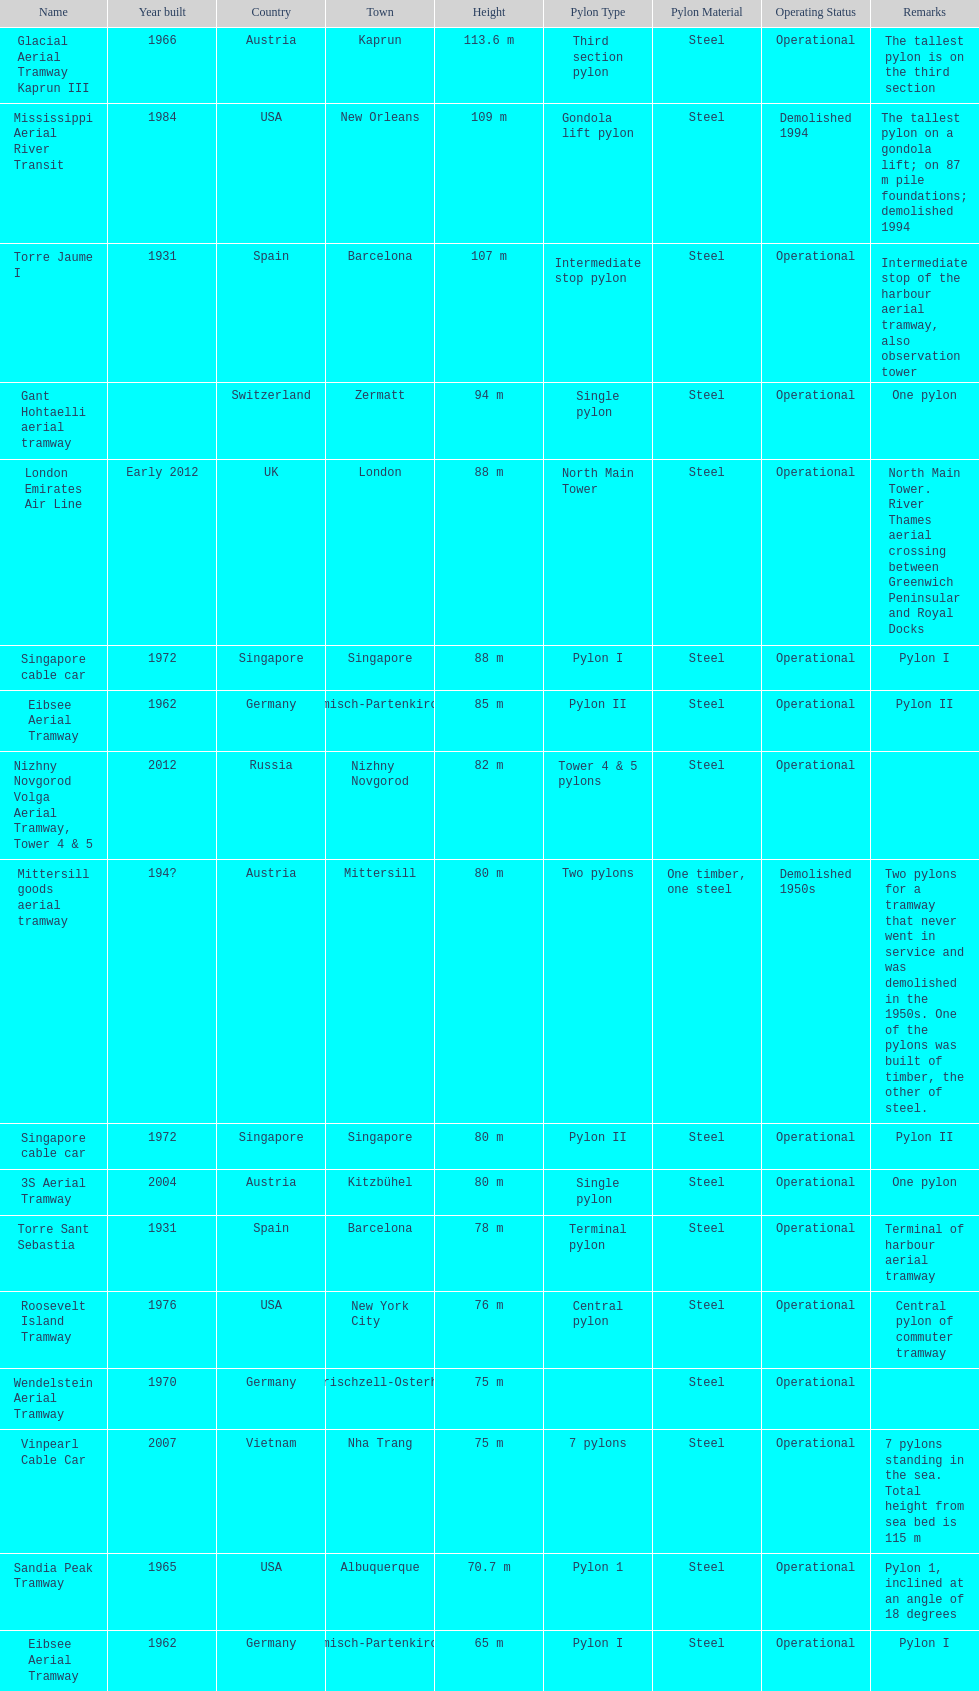Which pylon is the least tall? Eibsee Aerial Tramway. 